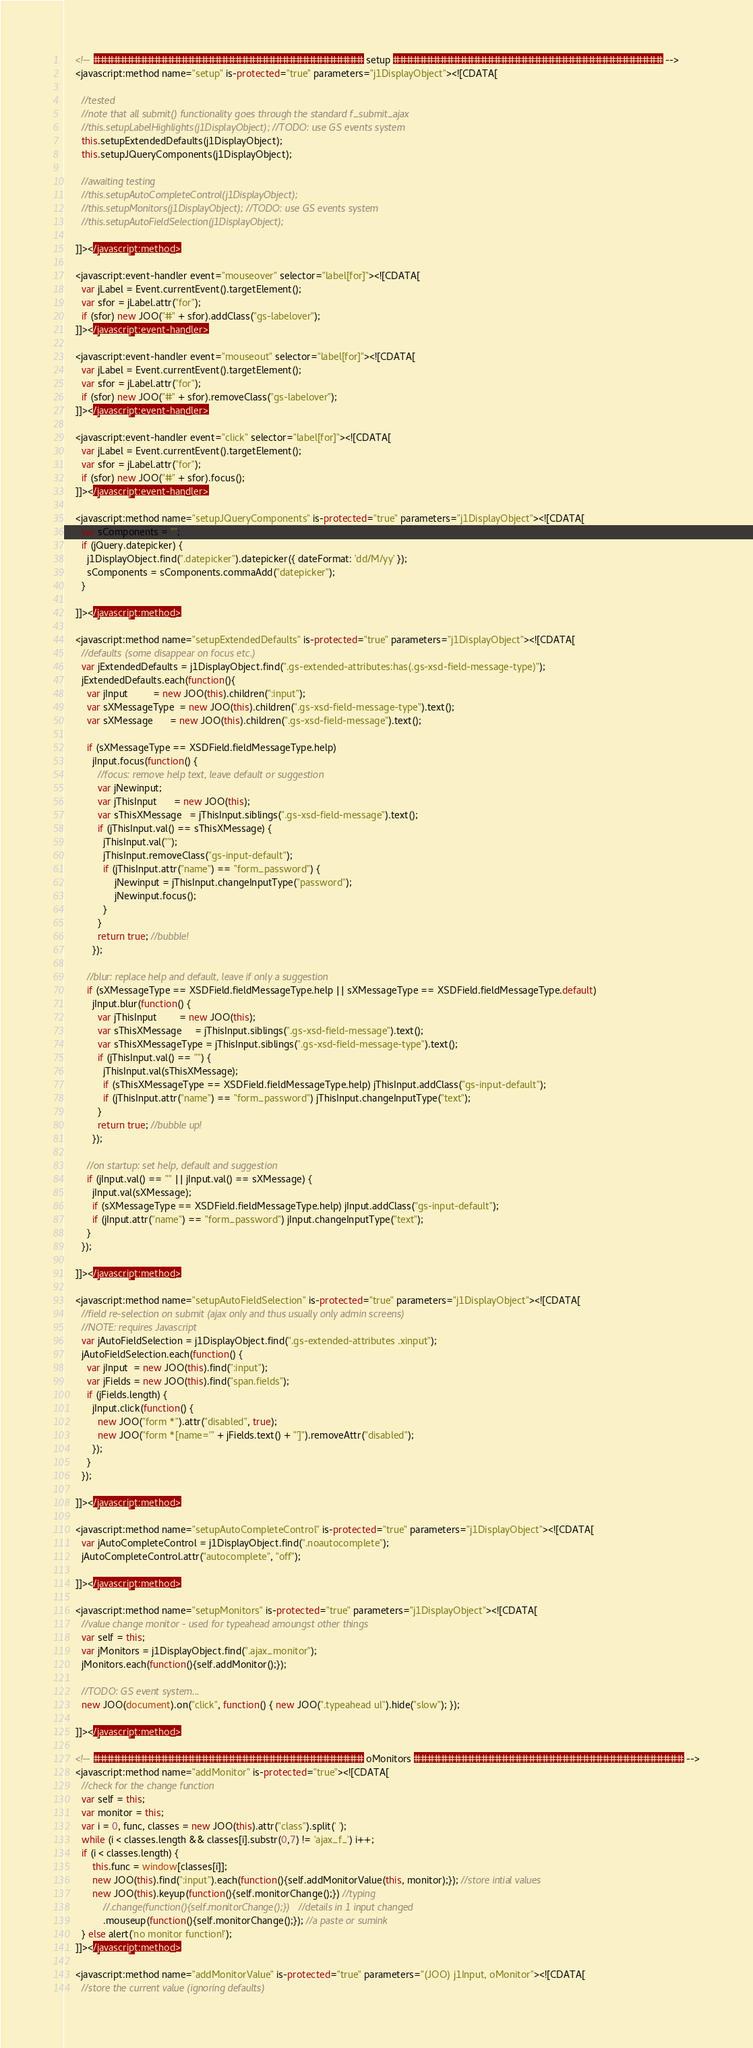Convert code to text. <code><loc_0><loc_0><loc_500><loc_500><_JavaScript_>    <!-- ######################################## setup ######################################## -->
    <javascript:method name="setup" is-protected="true" parameters="j1DisplayObject"><![CDATA[

      //tested
      //note that all submit() functionality goes through the standard f_submit_ajax
      //this.setupLabelHighlights(j1DisplayObject); //TODO: use GS events system
      this.setupExtendedDefaults(j1DisplayObject);
      this.setupJQueryComponents(j1DisplayObject);

      //awaiting testing
      //this.setupAutoCompleteControl(j1DisplayObject);
      //this.setupMonitors(j1DisplayObject); //TODO: use GS events system
      //this.setupAutoFieldSelection(j1DisplayObject);

    ]]></javascript:method>
    
    <javascript:event-handler event="mouseover" selector="label[for]"><![CDATA[
      var jLabel = Event.currentEvent().targetElement();
      var sfor = jLabel.attr("for");
      if (sfor) new JOO("#" + sfor).addClass("gs-labelover");
    ]]></javascript:event-handler>

    <javascript:event-handler event="mouseout" selector="label[for]"><![CDATA[
      var jLabel = Event.currentEvent().targetElement();
      var sfor = jLabel.attr("for");
      if (sfor) new JOO("#" + sfor).removeClass("gs-labelover");
    ]]></javascript:event-handler>

    <javascript:event-handler event="click" selector="label[for]"><![CDATA[
      var jLabel = Event.currentEvent().targetElement();
      var sfor = jLabel.attr("for");
      if (sfor) new JOO("#" + sfor).focus();
    ]]></javascript:event-handler>

    <javascript:method name="setupJQueryComponents" is-protected="true" parameters="j1DisplayObject"><![CDATA[
      var sComponents = "";
      if (jQuery.datepicker) {
        j1DisplayObject.find(".datepicker").datepicker({ dateFormat: 'dd/M/yy' });
        sComponents = sComponents.commaAdd("datepicker");
      }

    ]]></javascript:method>

    <javascript:method name="setupExtendedDefaults" is-protected="true" parameters="j1DisplayObject"><![CDATA[
      //defaults (some disappear on focus etc.)
      var jExtendedDefaults = j1DisplayObject.find(".gs-extended-attributes:has(.gs-xsd-field-message-type)");
      jExtendedDefaults.each(function(){
        var jInput         = new JOO(this).children(":input");
        var sXMessageType  = new JOO(this).children(".gs-xsd-field-message-type").text();
        var sXMessage      = new JOO(this).children(".gs-xsd-field-message").text();

        if (sXMessageType == XSDField.fieldMessageType.help)
          jInput.focus(function() {
            //focus: remove help text, leave default or suggestion
            var jNewinput;
            var jThisInput      = new JOO(this);
            var sThisXMessage   = jThisInput.siblings(".gs-xsd-field-message").text();
            if (jThisInput.val() == sThisXMessage) {
              jThisInput.val("");
              jThisInput.removeClass("gs-input-default");
              if (jThisInput.attr("name") == "form_password") {
                  jNewinput = jThisInput.changeInputType("password");
                  jNewinput.focus();
              }
            }
            return true; //bubble!
          });

        //blur: replace help and default, leave if only a suggestion
        if (sXMessageType == XSDField.fieldMessageType.help || sXMessageType == XSDField.fieldMessageType.default)
          jInput.blur(function() {
            var jThisInput        = new JOO(this);
            var sThisXMessage     = jThisInput.siblings(".gs-xsd-field-message").text();
            var sThisXMessageType = jThisInput.siblings(".gs-xsd-field-message-type").text();
            if (jThisInput.val() == "") {
              jThisInput.val(sThisXMessage);
              if (sThisXMessageType == XSDField.fieldMessageType.help) jThisInput.addClass("gs-input-default");
              if (jThisInput.attr("name") == "form_password") jThisInput.changeInputType("text");
            }
            return true; //bubble up!
          });

        //on startup: set help, default and suggestion
        if (jInput.val() == "" || jInput.val() == sXMessage) {
          jInput.val(sXMessage);
          if (sXMessageType == XSDField.fieldMessageType.help) jInput.addClass("gs-input-default");
          if (jInput.attr("name") == "form_password") jInput.changeInputType("text");
        }
      });

    ]]></javascript:method>

    <javascript:method name="setupAutoFieldSelection" is-protected="true" parameters="j1DisplayObject"><![CDATA[
      //field re-selection on submit (ajax only and thus usually only admin screens)
      //NOTE: requires Javascript
      var jAutoFieldSelection = j1DisplayObject.find(".gs-extended-attributes .xinput");
      jAutoFieldSelection.each(function() {
        var jInput  = new JOO(this).find(":input");
        var jFields = new JOO(this).find("span.fields");
        if (jFields.length) {
          jInput.click(function() {
            new JOO("form *").attr("disabled", true);
            new JOO("form *[name='" + jFields.text() + "']").removeAttr("disabled");
          });
        }
      });

    ]]></javascript:method>

    <javascript:method name="setupAutoCompleteControl" is-protected="true" parameters="j1DisplayObject"><![CDATA[
      var jAutoCompleteControl = j1DisplayObject.find(".noautocomplete");
      jAutoCompleteControl.attr("autocomplete", "off");

    ]]></javascript:method>

    <javascript:method name="setupMonitors" is-protected="true" parameters="j1DisplayObject"><![CDATA[
      //value change monitor - used for typeahead amoungst other things
      var self = this;
      var jMonitors = j1DisplayObject.find(".ajax_monitor");
      jMonitors.each(function(){self.addMonitor();});
      
      //TODO: GS event system...
      new JOO(document).on("click", function() { new JOO(".typeahead ul").hide("slow"); });

    ]]></javascript:method>

    <!-- ######################################## oMonitors ######################################## -->
    <javascript:method name="addMonitor" is-protected="true"><![CDATA[
      //check for the change function
      var self = this;
      var monitor = this;
      var i = 0, func, classes = new JOO(this).attr("class").split(' ');
      while (i < classes.length && classes[i].substr(0,7) != 'ajax_f_') i++;
      if (i < classes.length) {
          this.func = window[classes[i]];
          new JOO(this).find(":input").each(function(){self.addMonitorValue(this, monitor);}); //store intial values
          new JOO(this).keyup(function(){self.monitorChange();}) //typing
              //.change(function(){self.monitorChange();})   //details in 1 input changed
              .mouseup(function(){self.monitorChange();}); //a paste or sumink
      } else alert('no monitor function!');
    ]]></javascript:method>

    <javascript:method name="addMonitorValue" is-protected="true" parameters="(JOO) j1Input, oMonitor"><![CDATA[
      //store the current value (ignoring defaults)</code> 